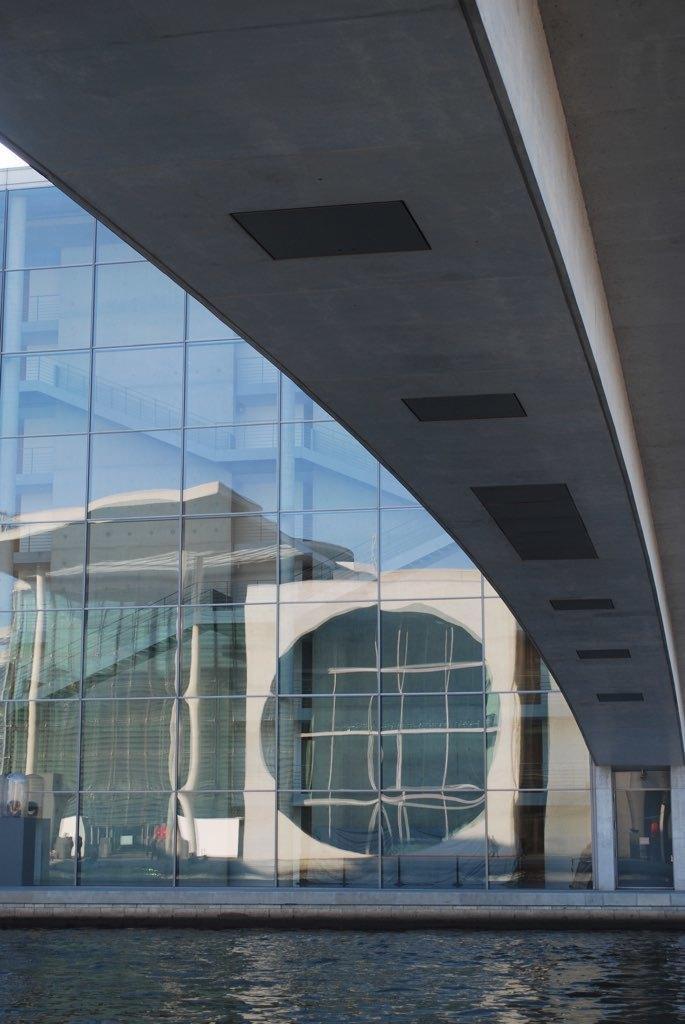How would you summarize this image in a sentence or two? In the image we can see a building made up of glass and here we can see water. 